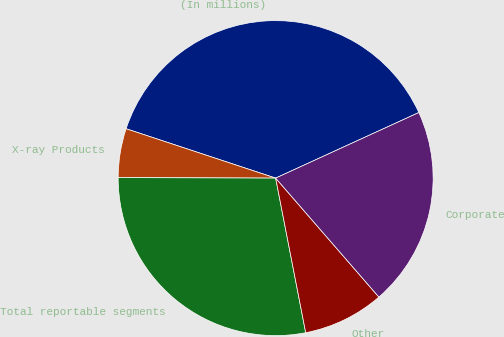Convert chart. <chart><loc_0><loc_0><loc_500><loc_500><pie_chart><fcel>(In millions)<fcel>X-ray Products<fcel>Total reportable segments<fcel>Other<fcel>Corporate<nl><fcel>38.09%<fcel>5.02%<fcel>28.11%<fcel>8.32%<fcel>20.46%<nl></chart> 